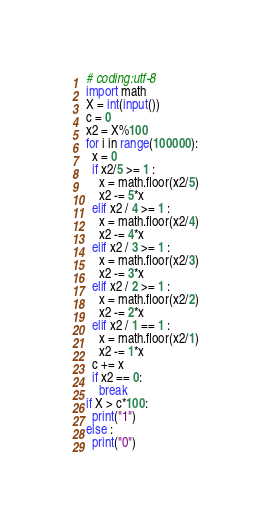Convert code to text. <code><loc_0><loc_0><loc_500><loc_500><_Python_># coding:utf-8
import math
X = int(input())
c = 0
x2 = X%100
for i in range(100000):
  x = 0
  if x2/5 >= 1 :
    x = math.floor(x2/5)
    x2 -= 5*x
  elif x2 / 4 >= 1 :
    x = math.floor(x2/4)
    x2 -= 4*x
  elif x2 / 3 >= 1 :
    x = math.floor(x2/3)
    x2 -= 3*x
  elif x2 / 2 >= 1 :
    x = math.floor(x2/2)
    x2 -= 2*x
  elif x2 / 1 == 1 :
    x = math.floor(x2/1)
    x2 -= 1*x
  c += x
  if x2 == 0:
    break
if X > c*100:
  print("1")
else :
  print("0")</code> 